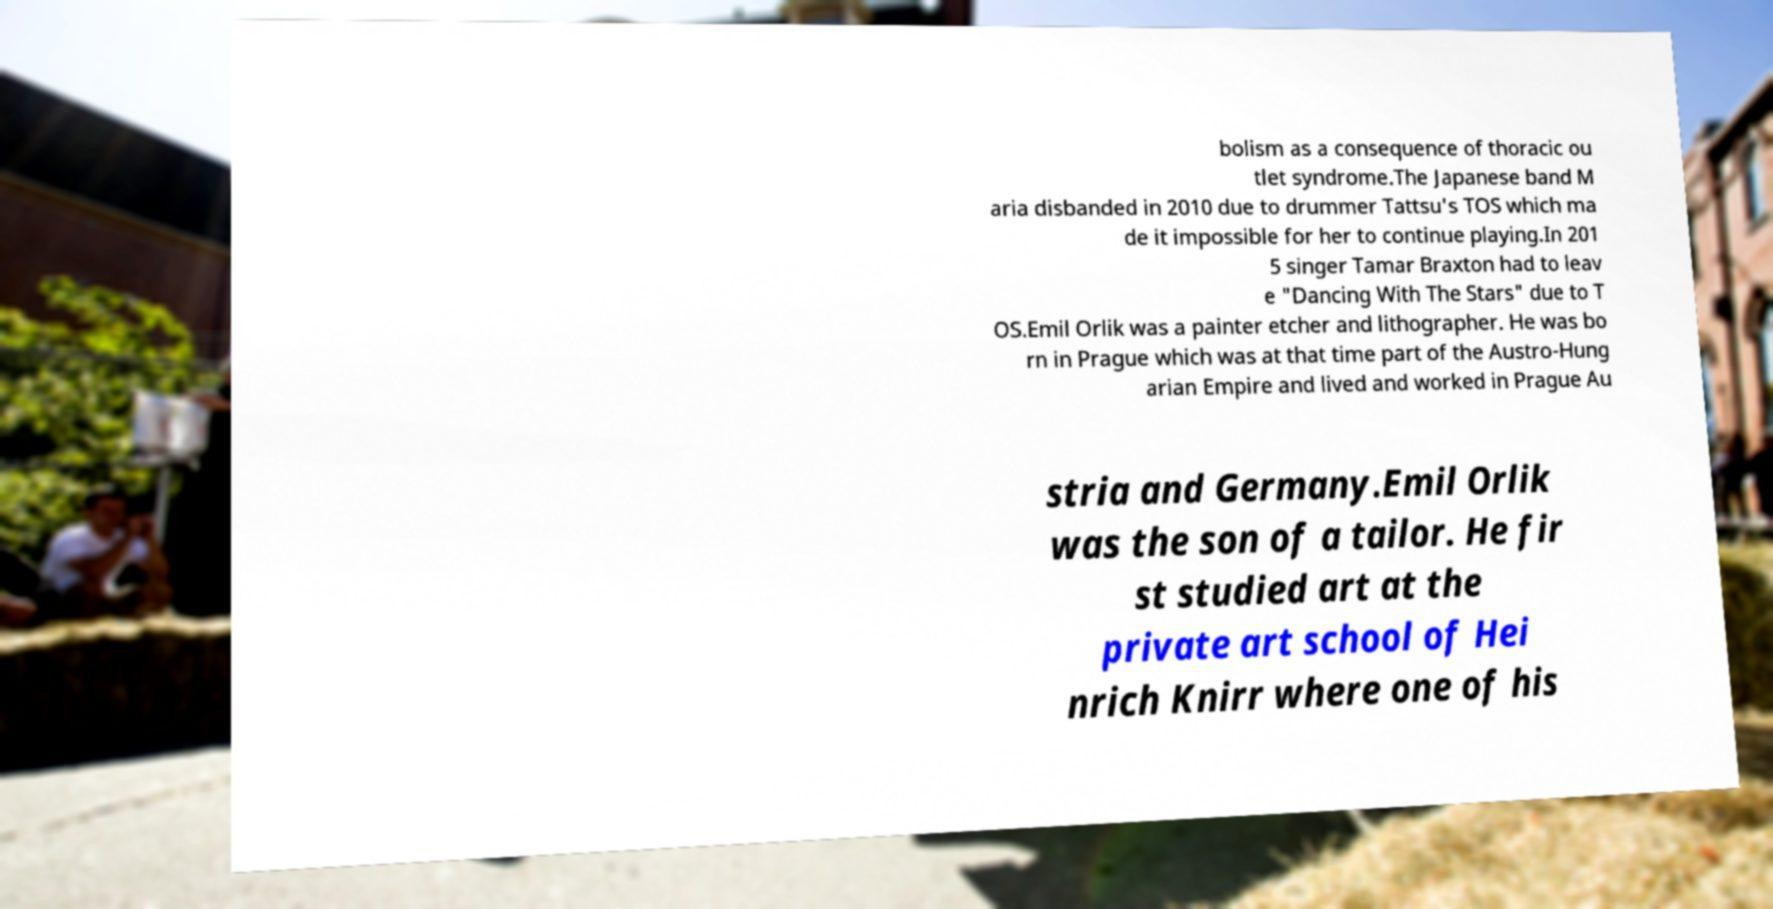Please read and relay the text visible in this image. What does it say? bolism as a consequence of thoracic ou tlet syndrome.The Japanese band M aria disbanded in 2010 due to drummer Tattsu's TOS which ma de it impossible for her to continue playing.In 201 5 singer Tamar Braxton had to leav e "Dancing With The Stars" due to T OS.Emil Orlik was a painter etcher and lithographer. He was bo rn in Prague which was at that time part of the Austro-Hung arian Empire and lived and worked in Prague Au stria and Germany.Emil Orlik was the son of a tailor. He fir st studied art at the private art school of Hei nrich Knirr where one of his 